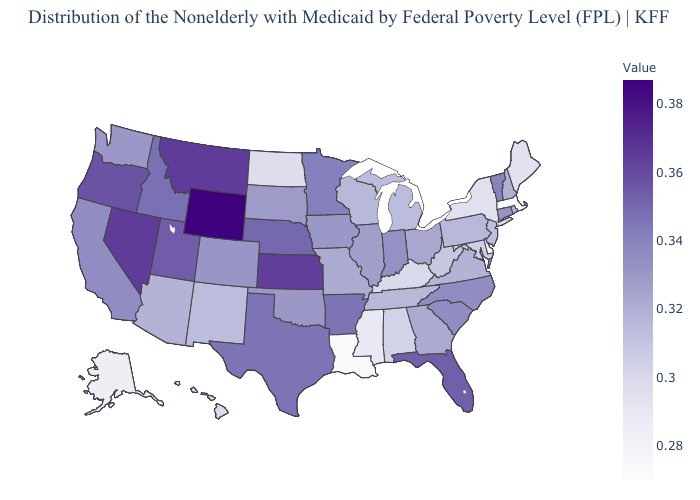Among the states that border Michigan , which have the lowest value?
Short answer required. Wisconsin. Which states have the lowest value in the West?
Write a very short answer. Alaska. Does Washington have a lower value than Nevada?
Give a very brief answer. Yes. 